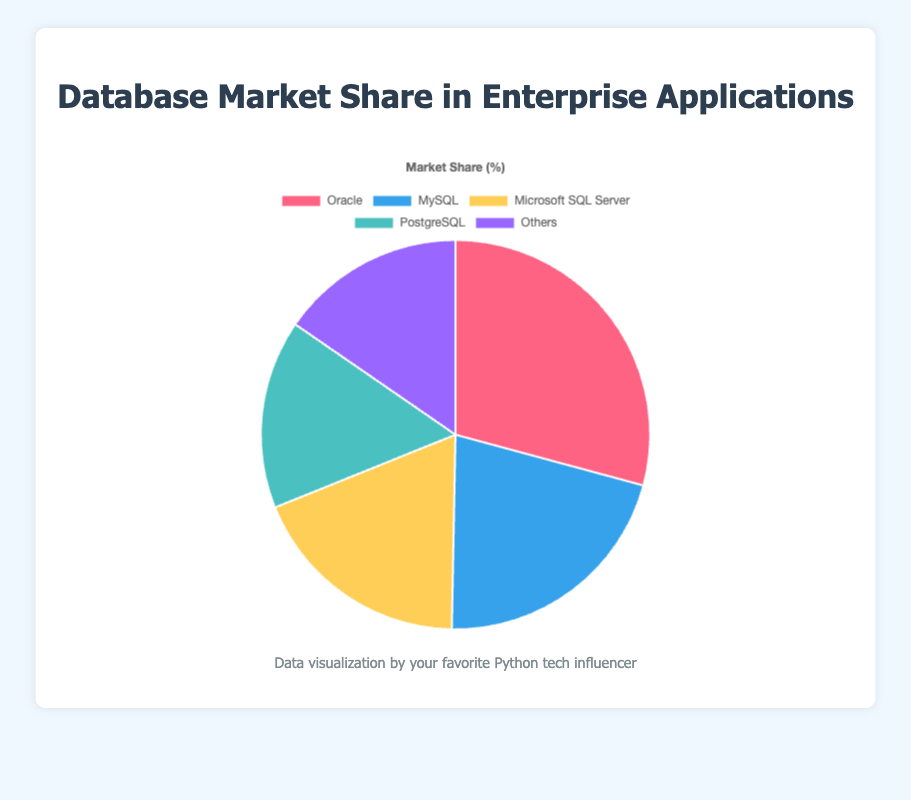What percentage of the market share is covered by Oracle and MySQL combined? To find the combined market share of Oracle and MySQL, add their individual market shares: Oracle (29.2%) + MySQL (21.1%) = 50.3%.
Answer: 50.3% Which database has a lower market share, PostgreSQL or Microsoft SQL Server? Compare the market share percentages of PostgreSQL (15.7%) and Microsoft SQL Server (18.6%). PostgreSQL has a lower percentage.
Answer: PostgreSQL How much more market share does Oracle have compared to PostgreSQL? Subtract the market share of PostgreSQL (15.7%) from the market share of Oracle (29.2%). 29.2% - 15.7% = 13.5%.
Answer: 13.5% Which database has the smallest market share and what is its percentage? Identify the database with the smallest percentage: Others (15.4%).
Answer: Others, 15.4% What is the average market share of the top three databases? Calculate the average of the market shares of Oracle (29.2%), MySQL (21.1%), and Microsoft SQL Server (18.6%). (29.2% + 21.1% + 18.6%) / 3 = 23%.
Answer: 23% Which database is represented by the yellow color in the pie chart? The pie chart shows Microsoft SQL Server as the segment with yellow color.
Answer: Microsoft SQL Server How does the market share of MySQL compare to "Others"? Compare the percentages: MySQL (21.1%) has a higher market share than "Others" (15.4%).
Answer: MySQL has a higher market share What is the difference in market share between the database with the highest share and the database with the lowest share? Subtract the market share of the lowest (Others, 15.4%) from the highest (Oracle, 29.2%). 29.2% - 15.4% = 13.8%.
Answer: 13.8% Which databases have a combined market share close to 37%? Add the market shares: PostgreSQL (15.7%) + Others (15.4%) = 31.1%. This is not close to 37%. Instead, Oracle (29.2%) + Others (15.4%) = 44.6%. The closest combination is MySQL (21.1%) + Microsoft SQL Server (18.6%) = 39.7%.
Answer: MySQL and Microsoft SQL Server (39.7%) How many databases cover more than 20% of the market share each? Count the databases with market shares over 20%: Oracle (29.2%) and MySQL (21.1%) are the only two.
Answer: 2 